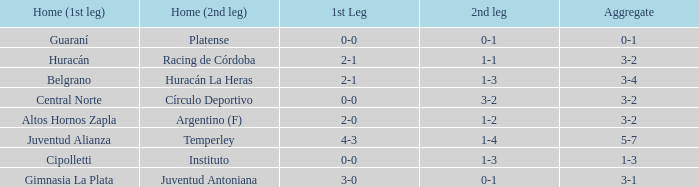Which team played the 2nd leg at home with a tie of 1-1 and scored 3-2 in aggregate? Racing de Córdoba. 